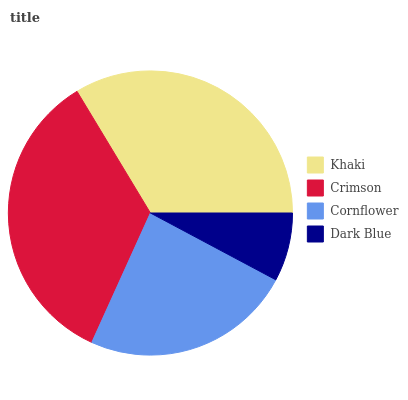Is Dark Blue the minimum?
Answer yes or no. Yes. Is Crimson the maximum?
Answer yes or no. Yes. Is Cornflower the minimum?
Answer yes or no. No. Is Cornflower the maximum?
Answer yes or no. No. Is Crimson greater than Cornflower?
Answer yes or no. Yes. Is Cornflower less than Crimson?
Answer yes or no. Yes. Is Cornflower greater than Crimson?
Answer yes or no. No. Is Crimson less than Cornflower?
Answer yes or no. No. Is Khaki the high median?
Answer yes or no. Yes. Is Cornflower the low median?
Answer yes or no. Yes. Is Dark Blue the high median?
Answer yes or no. No. Is Dark Blue the low median?
Answer yes or no. No. 